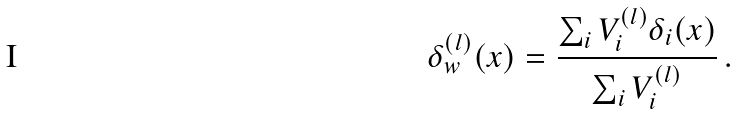<formula> <loc_0><loc_0><loc_500><loc_500>\delta _ { w } ^ { ( l ) } ( x ) = \frac { \sum _ { i } V ^ { ( l ) } _ { i } \delta _ { i } ( x ) } { \sum _ { i } V ^ { ( l ) } _ { i } } \, .</formula> 